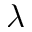Convert formula to latex. <formula><loc_0><loc_0><loc_500><loc_500>\lambda</formula> 